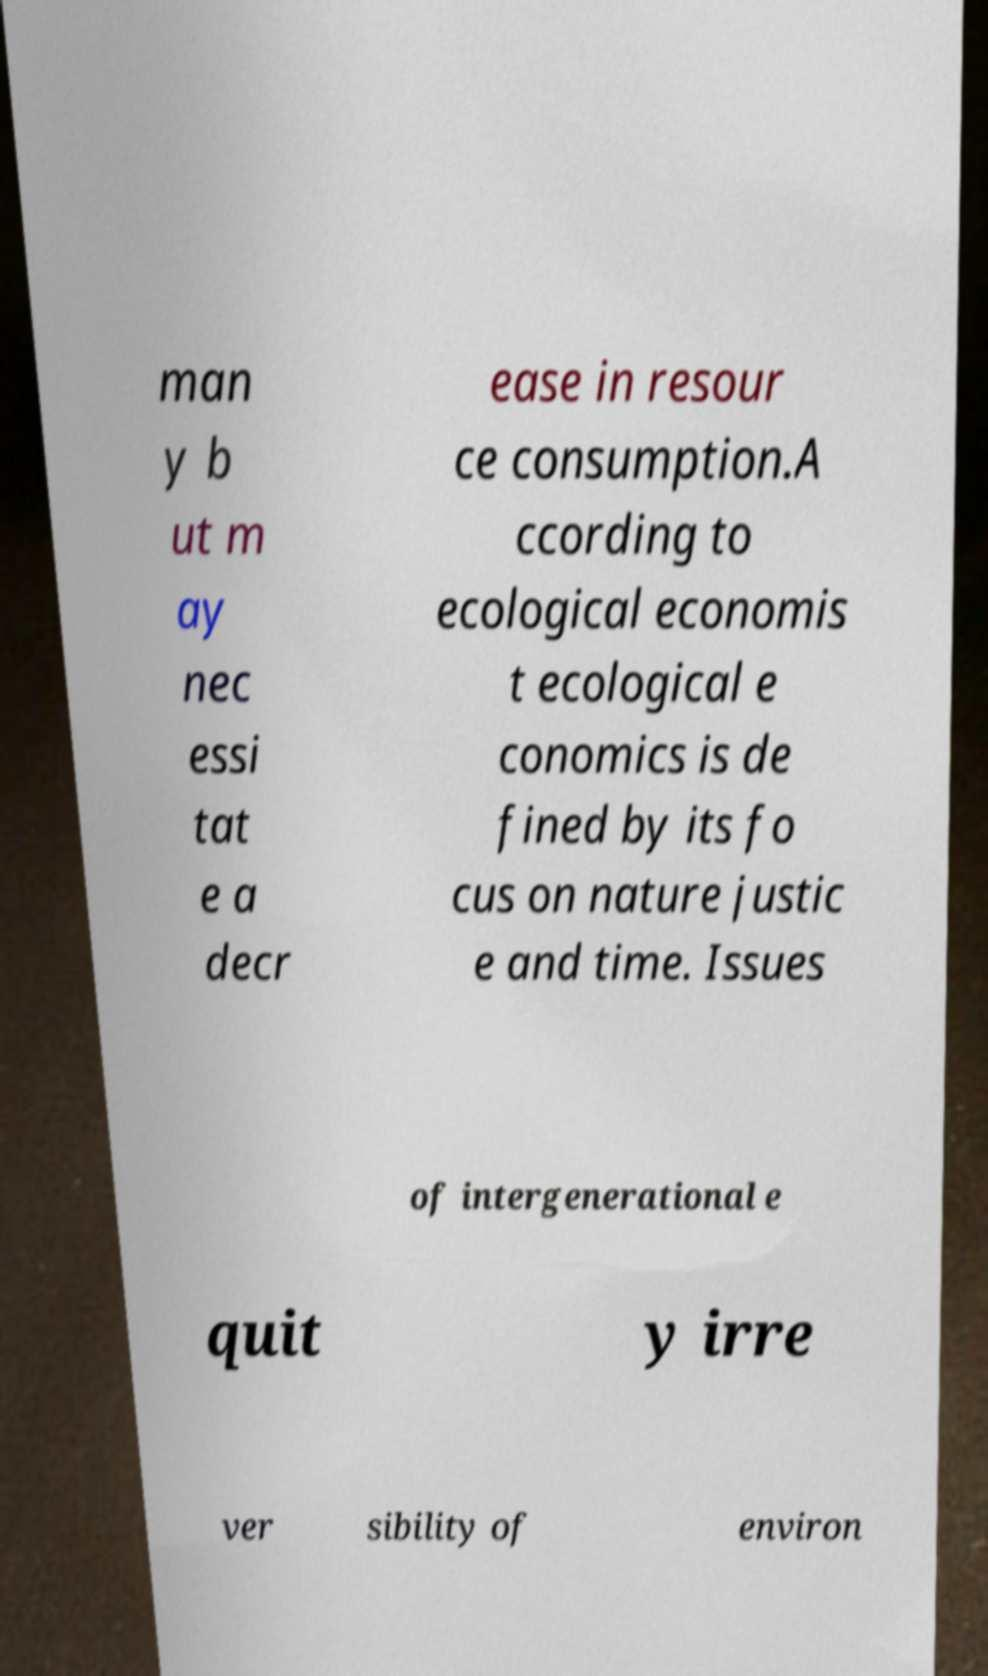Please read and relay the text visible in this image. What does it say? man y b ut m ay nec essi tat e a decr ease in resour ce consumption.A ccording to ecological economis t ecological e conomics is de fined by its fo cus on nature justic e and time. Issues of intergenerational e quit y irre ver sibility of environ 